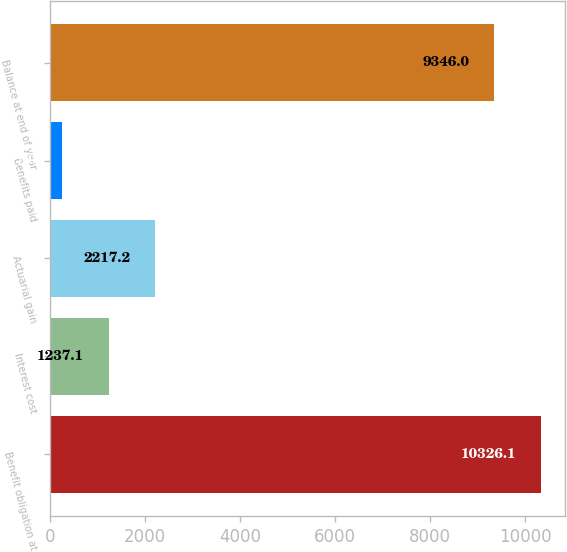Convert chart to OTSL. <chart><loc_0><loc_0><loc_500><loc_500><bar_chart><fcel>Benefit obligation at<fcel>Interest cost<fcel>Actuarial gain<fcel>Benefits paid<fcel>Balance at end of year<nl><fcel>10326.1<fcel>1237.1<fcel>2217.2<fcel>257<fcel>9346<nl></chart> 